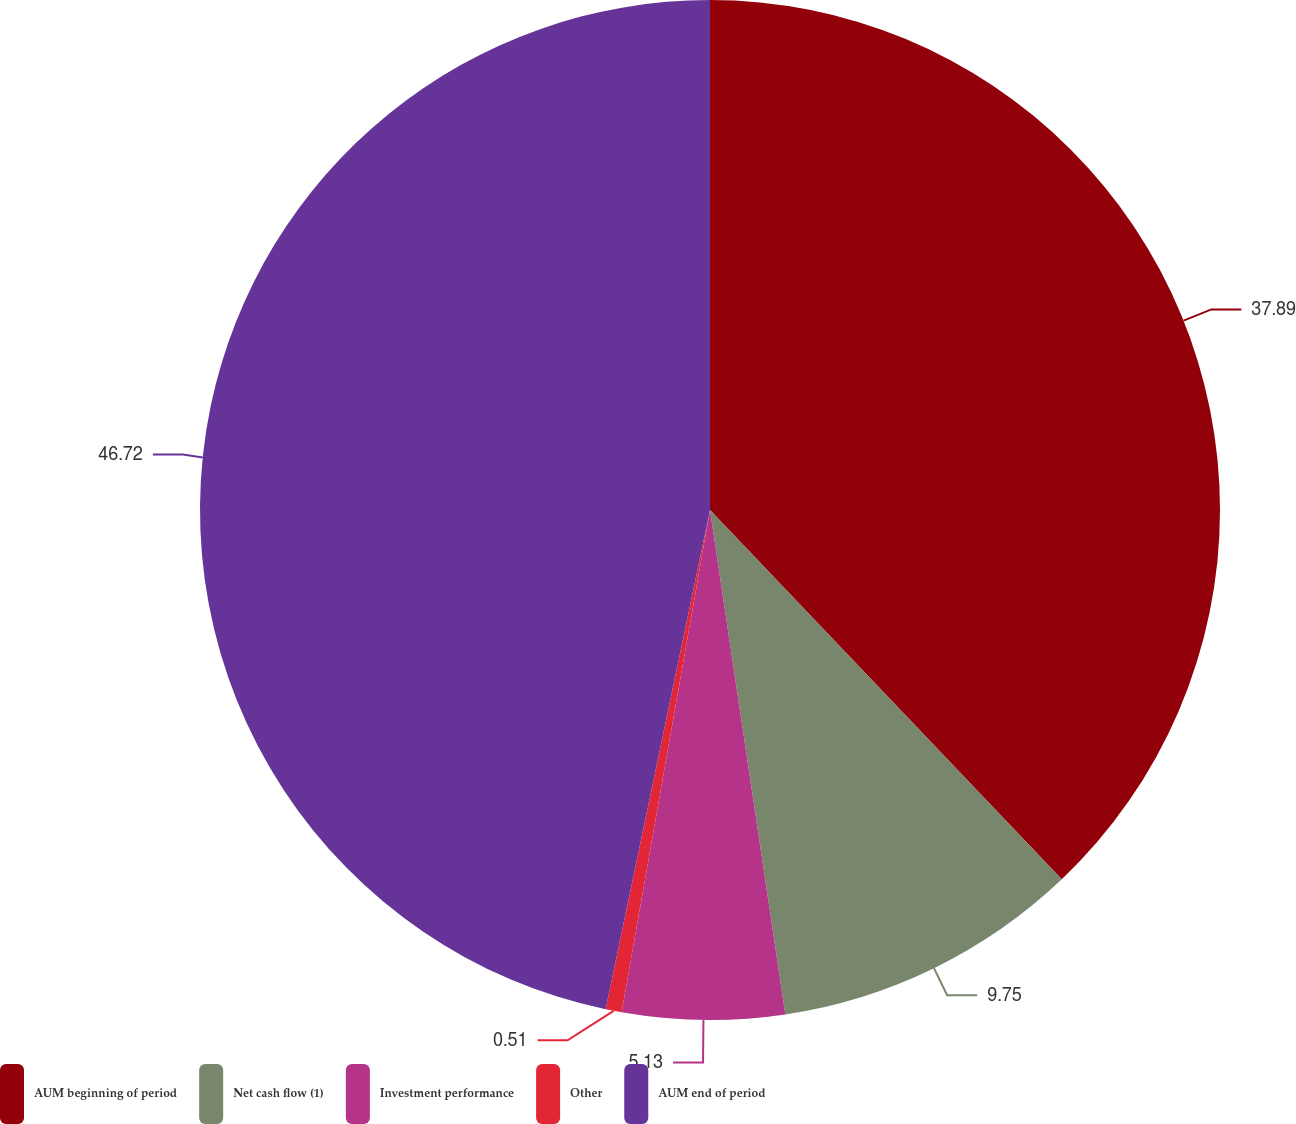Convert chart to OTSL. <chart><loc_0><loc_0><loc_500><loc_500><pie_chart><fcel>AUM beginning of period<fcel>Net cash flow (1)<fcel>Investment performance<fcel>Other<fcel>AUM end of period<nl><fcel>37.88%<fcel>9.75%<fcel>5.13%<fcel>0.51%<fcel>46.71%<nl></chart> 